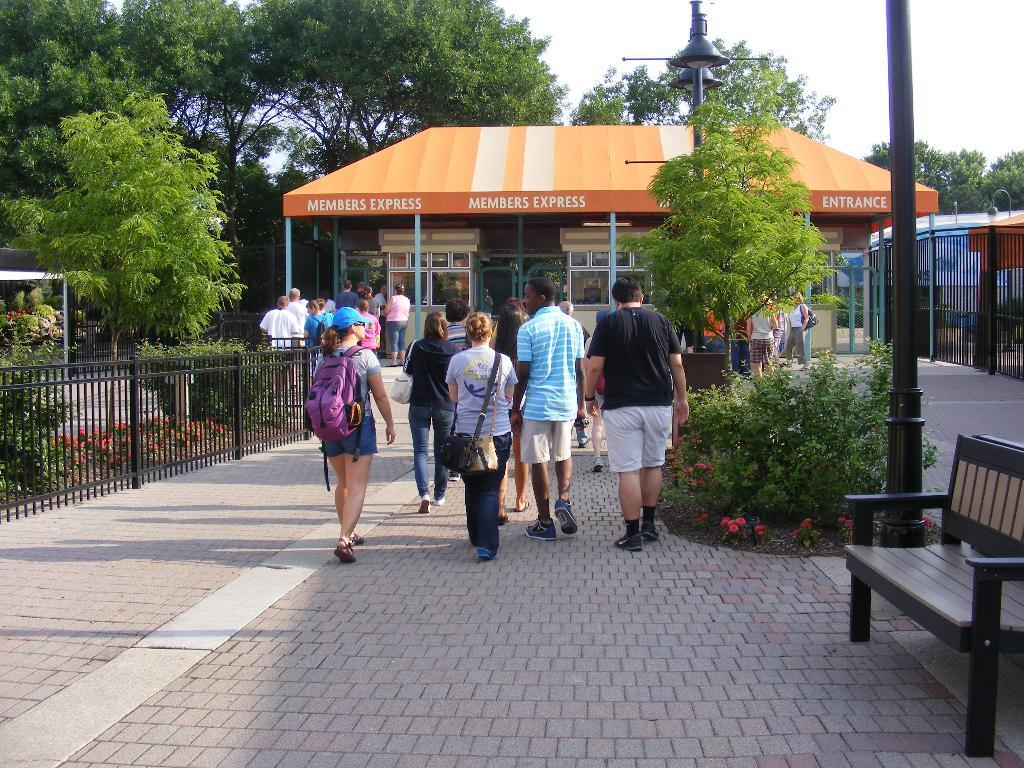What are the people in the image doing? There is a group of people walking in the image. On what surface are the people walking? The people are walking on a road. What can be seen in the background of the image? There is a building, a tree, plants, a fence, a bench, a pole, and the sky visible in the background of the image. How many slaves are sitting on the sofa in the image? There is no sofa or slaves present in the image. What type of chairs can be seen in the image? There are no chairs visible in the image. 